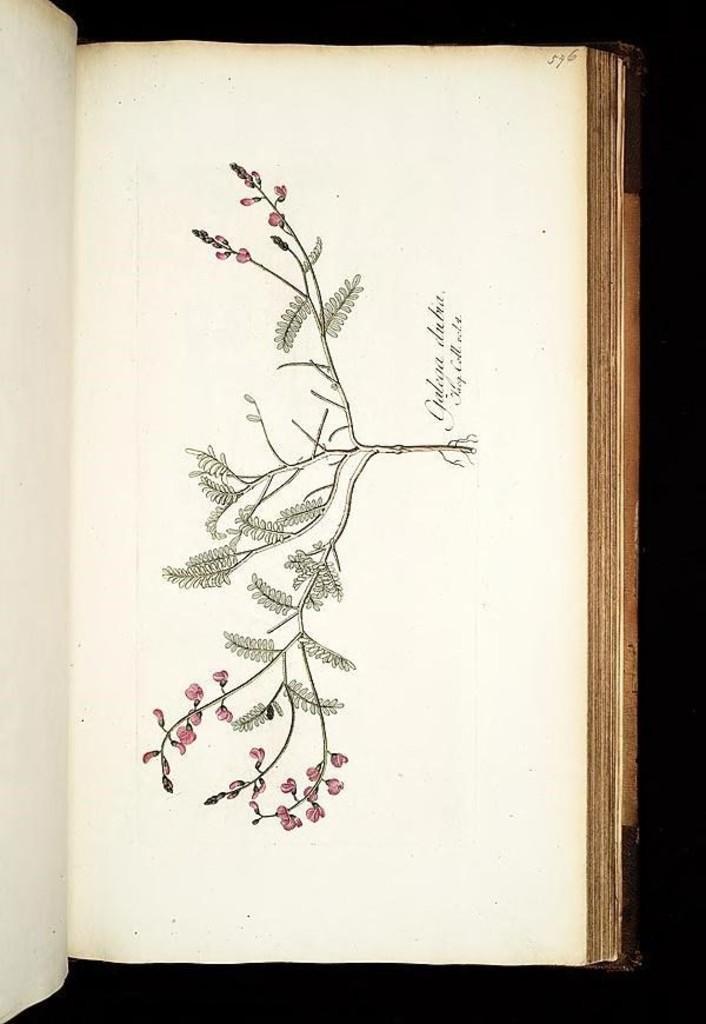Describe this image in one or two sentences. This is the picture of a book. In this image there is a painting of a plant in the book and there are pink color flowers on the plant and there is a text. 